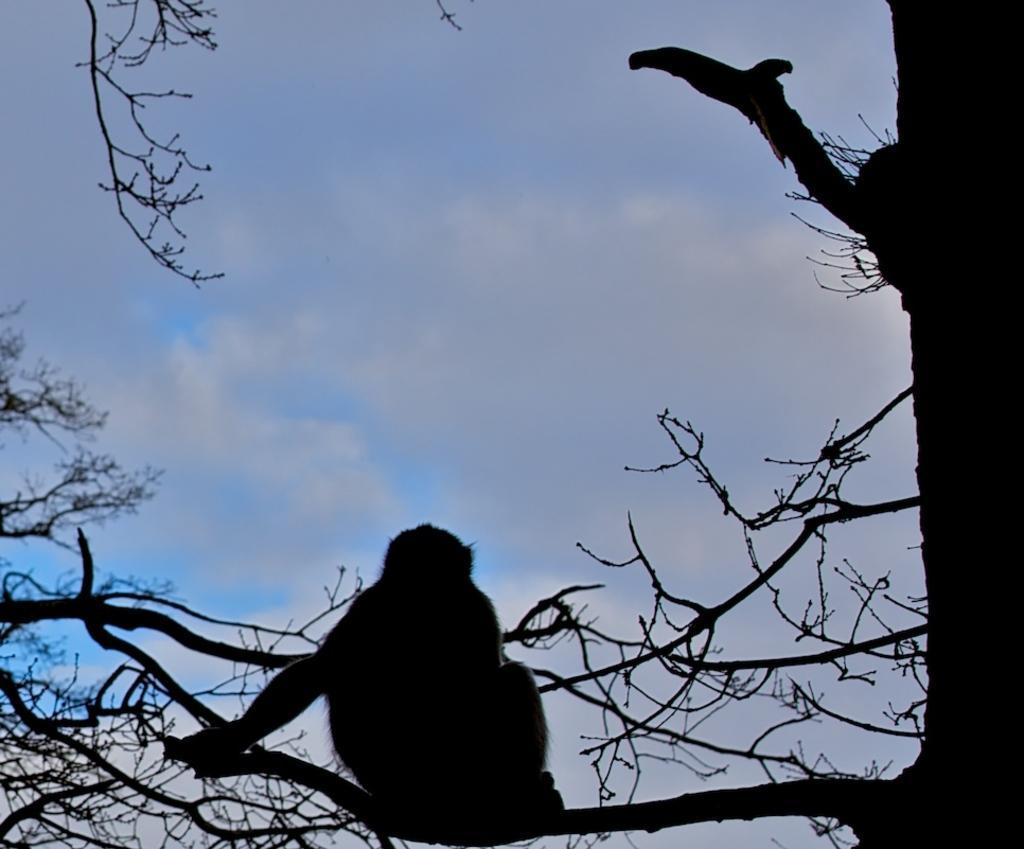How would you summarize this image in a sentence or two? In this image we can see an animal sitting on the branches and we can also see the sky. 